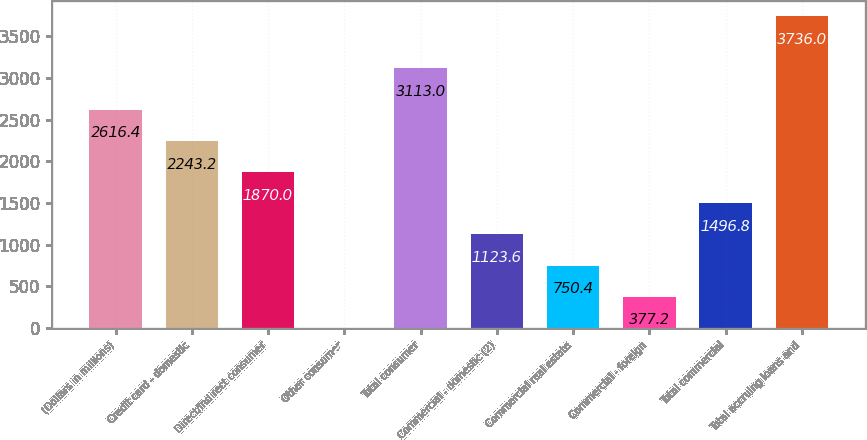Convert chart. <chart><loc_0><loc_0><loc_500><loc_500><bar_chart><fcel>(Dollars in millions)<fcel>Credit card - domestic<fcel>Direct/Indirect consumer<fcel>Other consumer<fcel>Total consumer<fcel>Commercial - domestic (2)<fcel>Commercial real estate<fcel>Commercial - foreign<fcel>Total commercial<fcel>Total accruing loans and<nl><fcel>2616.4<fcel>2243.2<fcel>1870<fcel>4<fcel>3113<fcel>1123.6<fcel>750.4<fcel>377.2<fcel>1496.8<fcel>3736<nl></chart> 